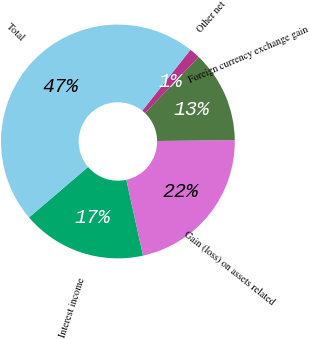Convert chart to OTSL. <chart><loc_0><loc_0><loc_500><loc_500><pie_chart><fcel>Interest income<fcel>Gain (loss) on assets related<fcel>Foreign currency exchange gain<fcel>Other net<fcel>Total<nl><fcel>17.2%<fcel>21.74%<fcel>12.66%<fcel>1.49%<fcel>46.91%<nl></chart> 